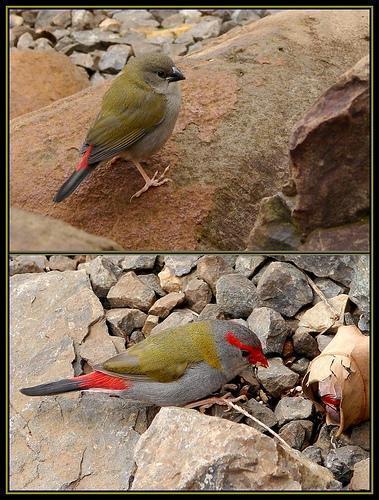How many birds can be seen?
Give a very brief answer. 2. 